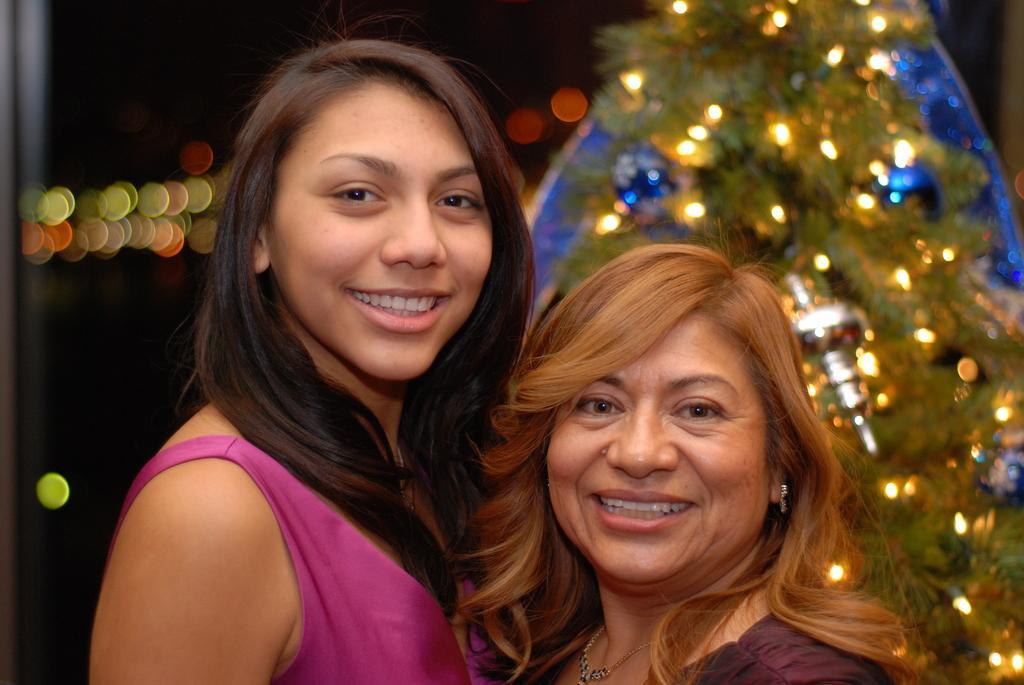How would you summarize this image in a sentence or two? There are two women standing and smiling. This looks like a tree with the lighting's. 